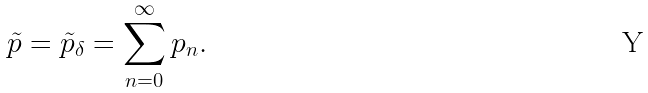Convert formula to latex. <formula><loc_0><loc_0><loc_500><loc_500>\tilde { p } = \tilde { p } _ { \delta } = \sum _ { n = 0 } ^ { \infty } p _ { n } .</formula> 